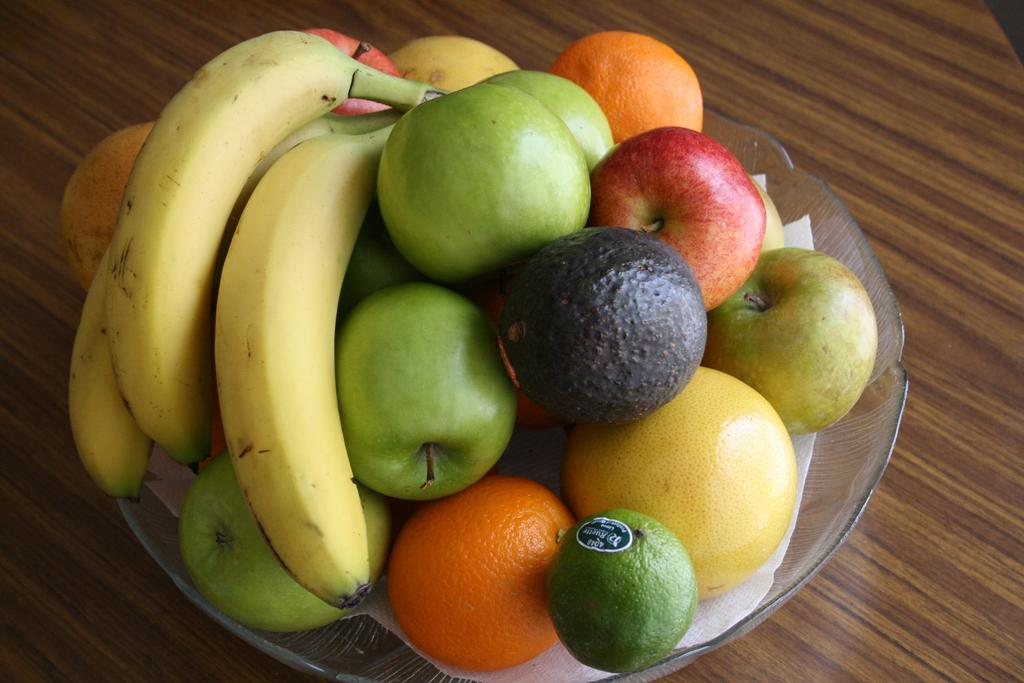What type of food can be seen in the image? There are fruits in the image. How are the fruits arranged in the image? The fruits are in a bowl. Can you see a letter being written by the fruits in the image? There is no letter or writing activity present in the image; it features fruits in a bowl. 